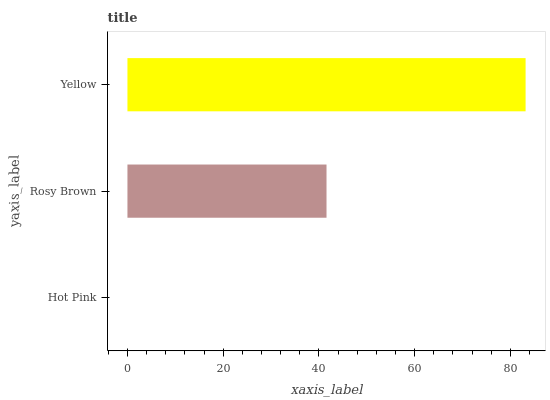Is Hot Pink the minimum?
Answer yes or no. Yes. Is Yellow the maximum?
Answer yes or no. Yes. Is Rosy Brown the minimum?
Answer yes or no. No. Is Rosy Brown the maximum?
Answer yes or no. No. Is Rosy Brown greater than Hot Pink?
Answer yes or no. Yes. Is Hot Pink less than Rosy Brown?
Answer yes or no. Yes. Is Hot Pink greater than Rosy Brown?
Answer yes or no. No. Is Rosy Brown less than Hot Pink?
Answer yes or no. No. Is Rosy Brown the high median?
Answer yes or no. Yes. Is Rosy Brown the low median?
Answer yes or no. Yes. Is Yellow the high median?
Answer yes or no. No. Is Hot Pink the low median?
Answer yes or no. No. 